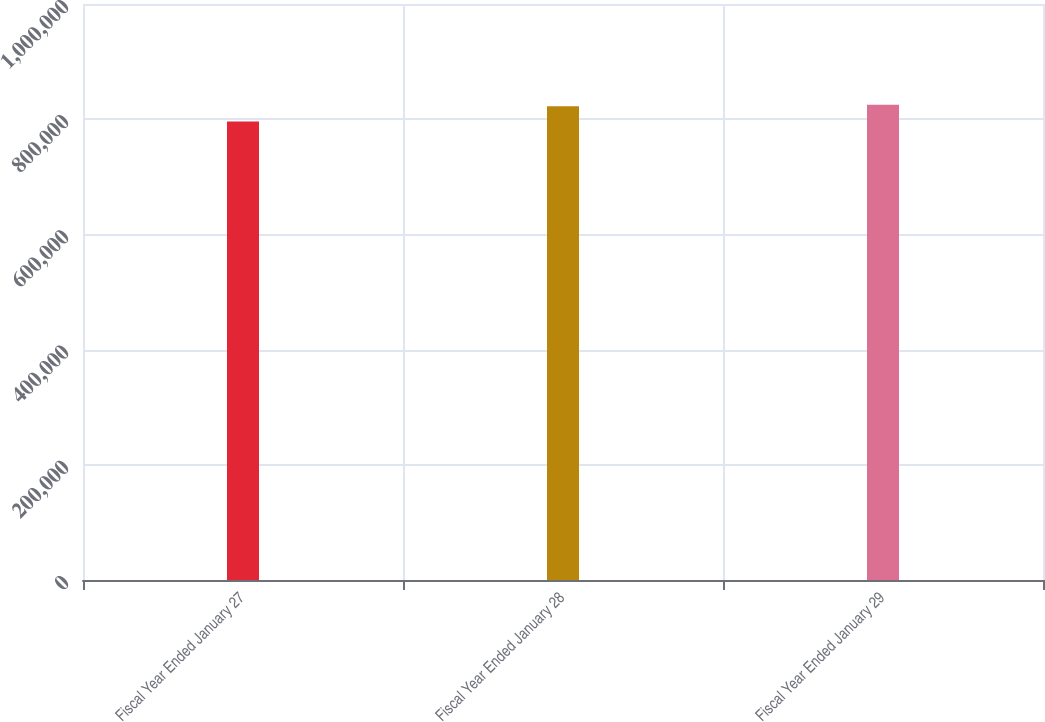Convert chart. <chart><loc_0><loc_0><loc_500><loc_500><bar_chart><fcel>Fiscal Year Ended January 27<fcel>Fiscal Year Ended January 28<fcel>Fiscal Year Ended January 29<nl><fcel>795860<fcel>822418<fcel>825255<nl></chart> 